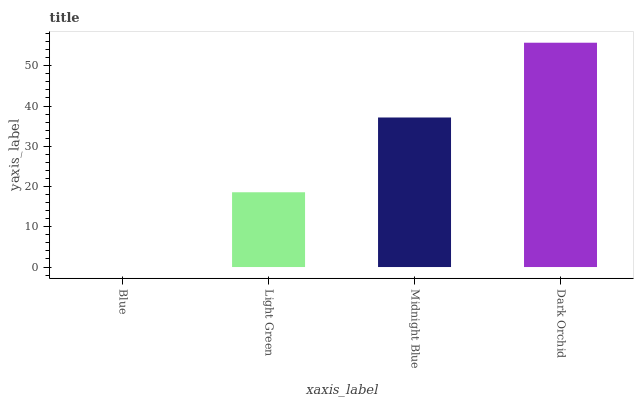Is Light Green the minimum?
Answer yes or no. No. Is Light Green the maximum?
Answer yes or no. No. Is Light Green greater than Blue?
Answer yes or no. Yes. Is Blue less than Light Green?
Answer yes or no. Yes. Is Blue greater than Light Green?
Answer yes or no. No. Is Light Green less than Blue?
Answer yes or no. No. Is Midnight Blue the high median?
Answer yes or no. Yes. Is Light Green the low median?
Answer yes or no. Yes. Is Blue the high median?
Answer yes or no. No. Is Blue the low median?
Answer yes or no. No. 